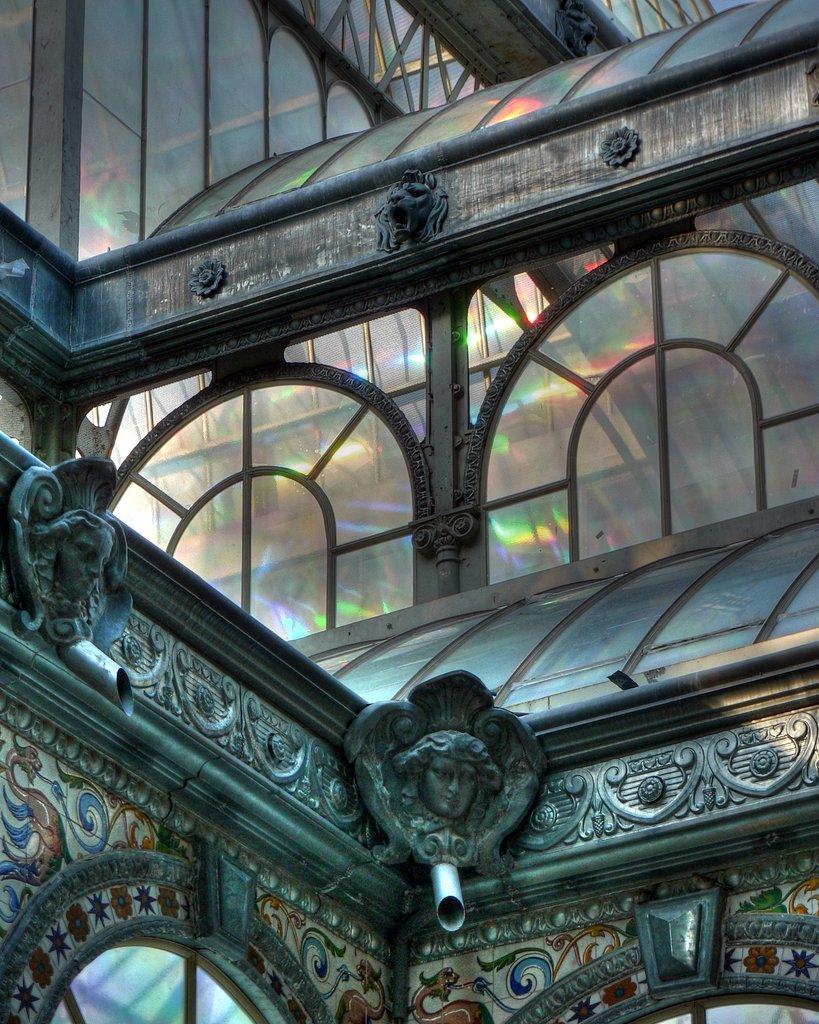Can you describe this image briefly? In this image, we can see glass building, pipes, sculptures and carvings. 